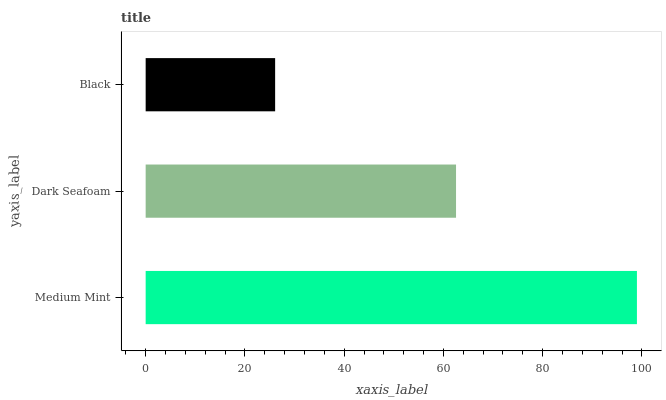Is Black the minimum?
Answer yes or no. Yes. Is Medium Mint the maximum?
Answer yes or no. Yes. Is Dark Seafoam the minimum?
Answer yes or no. No. Is Dark Seafoam the maximum?
Answer yes or no. No. Is Medium Mint greater than Dark Seafoam?
Answer yes or no. Yes. Is Dark Seafoam less than Medium Mint?
Answer yes or no. Yes. Is Dark Seafoam greater than Medium Mint?
Answer yes or no. No. Is Medium Mint less than Dark Seafoam?
Answer yes or no. No. Is Dark Seafoam the high median?
Answer yes or no. Yes. Is Dark Seafoam the low median?
Answer yes or no. Yes. Is Medium Mint the high median?
Answer yes or no. No. Is Medium Mint the low median?
Answer yes or no. No. 